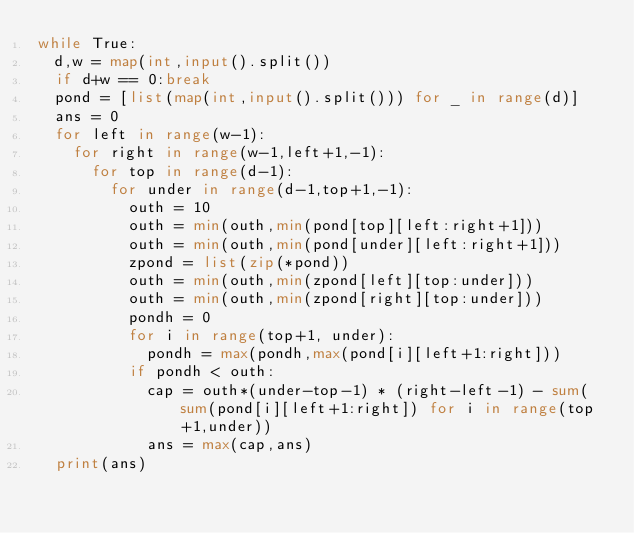<code> <loc_0><loc_0><loc_500><loc_500><_Python_>while True:
	d,w = map(int,input().split())
	if d+w == 0:break
	pond = [list(map(int,input().split())) for _ in range(d)]
	ans = 0
	for left in range(w-1):
		for right in range(w-1,left+1,-1):
			for top in range(d-1):
				for under in range(d-1,top+1,-1):
					outh = 10
					outh = min(outh,min(pond[top][left:right+1]))
					outh = min(outh,min(pond[under][left:right+1]))
					zpond = list(zip(*pond))
					outh = min(outh,min(zpond[left][top:under]))
					outh = min(outh,min(zpond[right][top:under]))
					pondh = 0
					for i in range(top+1, under):
						pondh = max(pondh,max(pond[i][left+1:right]))
					if pondh < outh:
						cap = outh*(under-top-1) * (right-left-1) - sum(sum(pond[i][left+1:right]) for i in range(top+1,under))
						ans = max(cap,ans)
	print(ans)
</code> 